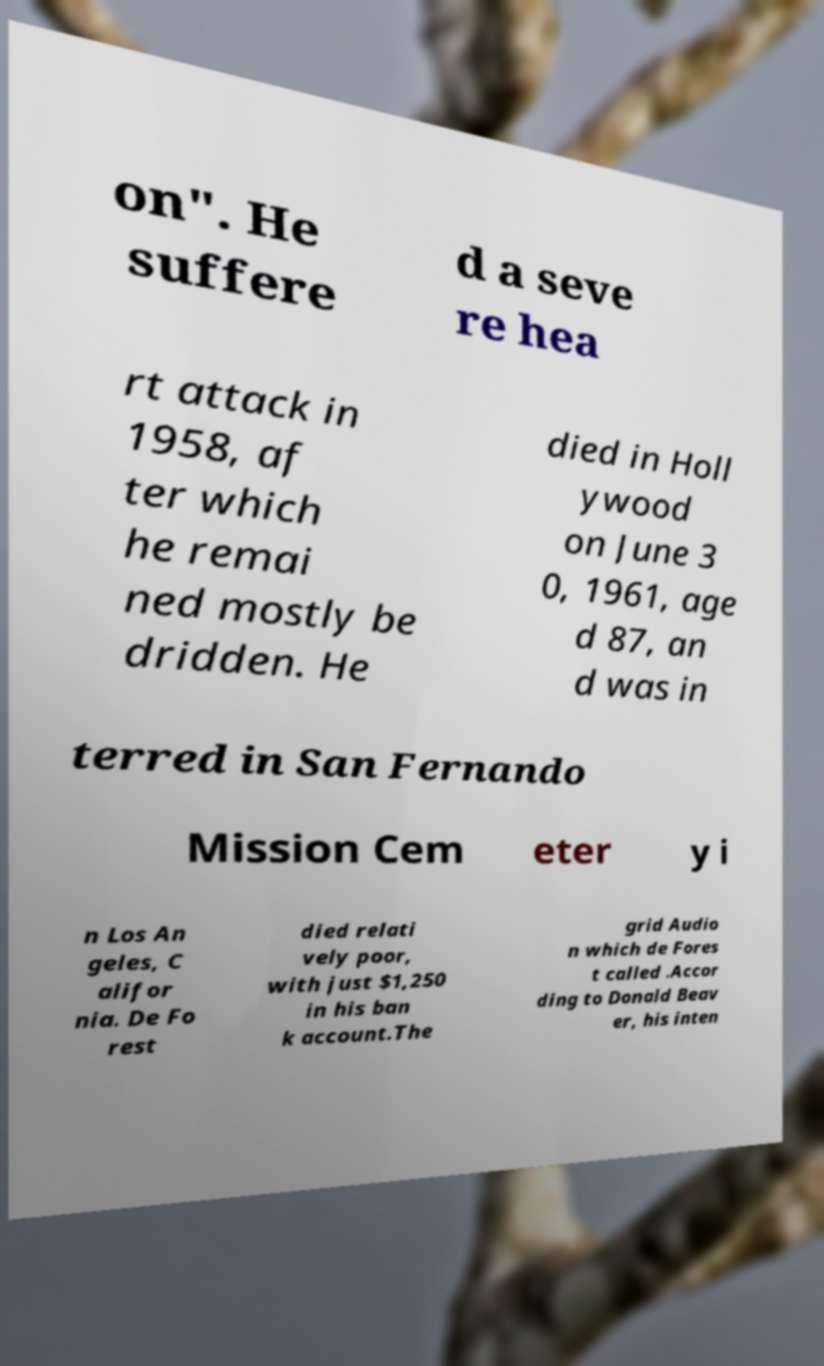Please read and relay the text visible in this image. What does it say? on". He suffere d a seve re hea rt attack in 1958, af ter which he remai ned mostly be dridden. He died in Holl ywood on June 3 0, 1961, age d 87, an d was in terred in San Fernando Mission Cem eter y i n Los An geles, C alifor nia. De Fo rest died relati vely poor, with just $1,250 in his ban k account.The grid Audio n which de Fores t called .Accor ding to Donald Beav er, his inten 